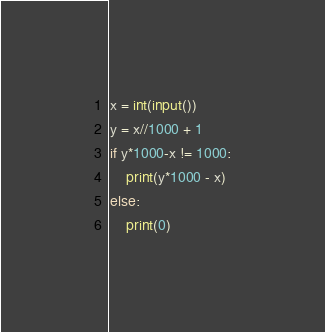<code> <loc_0><loc_0><loc_500><loc_500><_Python_>x = int(input())
y = x//1000 + 1
if y*1000-x != 1000:
    print(y*1000 - x)
else:
    print(0)</code> 